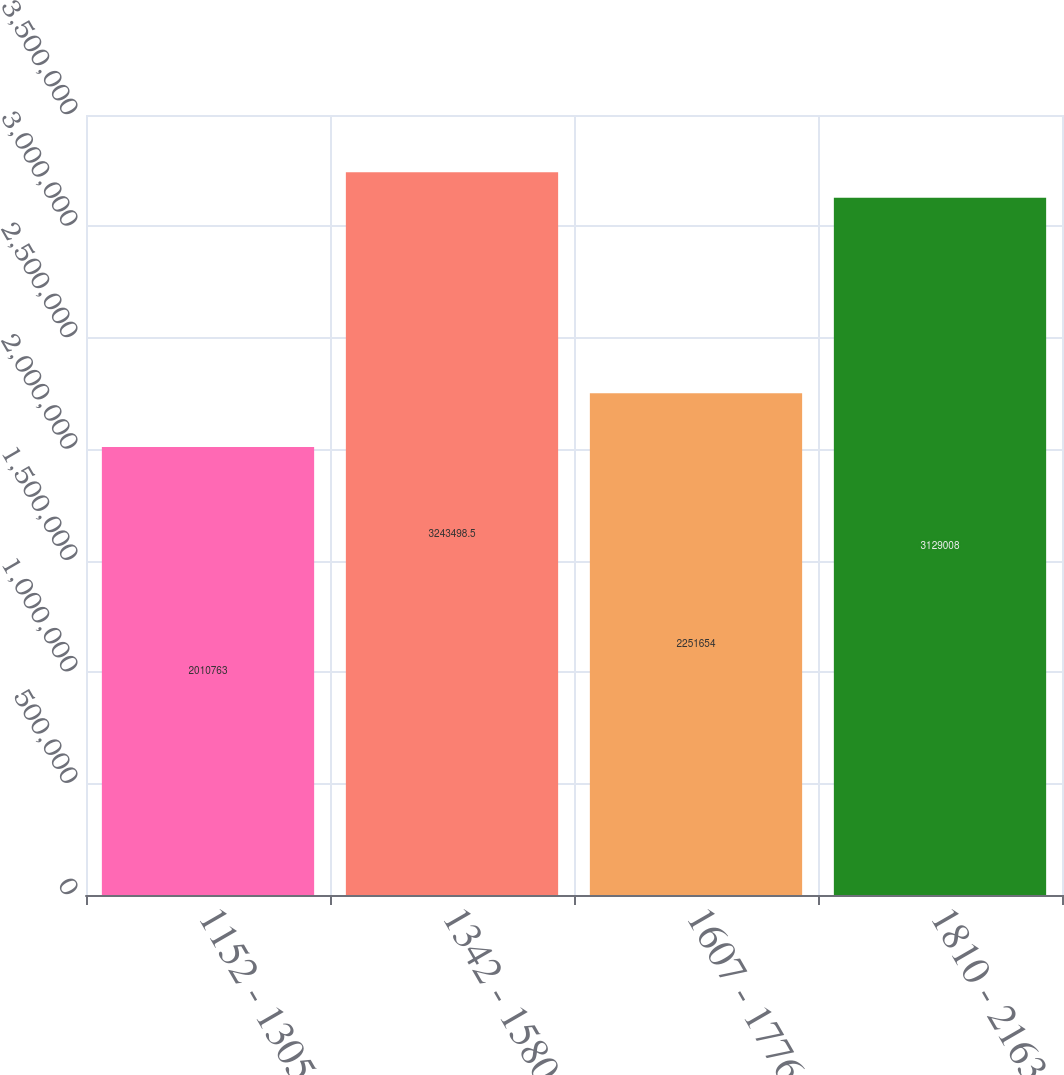Convert chart. <chart><loc_0><loc_0><loc_500><loc_500><bar_chart><fcel>1152 - 1305<fcel>1342 - 1580<fcel>1607 - 1776<fcel>1810 - 2163<nl><fcel>2.01076e+06<fcel>3.2435e+06<fcel>2.25165e+06<fcel>3.12901e+06<nl></chart> 